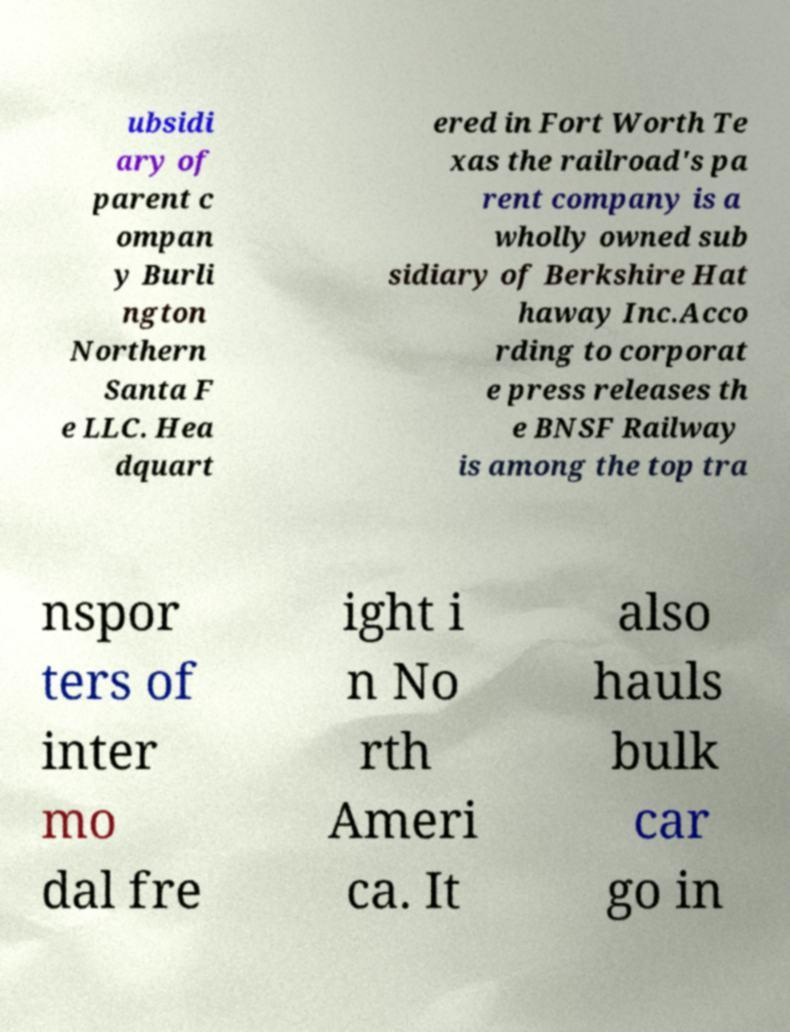What messages or text are displayed in this image? I need them in a readable, typed format. ubsidi ary of parent c ompan y Burli ngton Northern Santa F e LLC. Hea dquart ered in Fort Worth Te xas the railroad's pa rent company is a wholly owned sub sidiary of Berkshire Hat haway Inc.Acco rding to corporat e press releases th e BNSF Railway is among the top tra nspor ters of inter mo dal fre ight i n No rth Ameri ca. It also hauls bulk car go in 